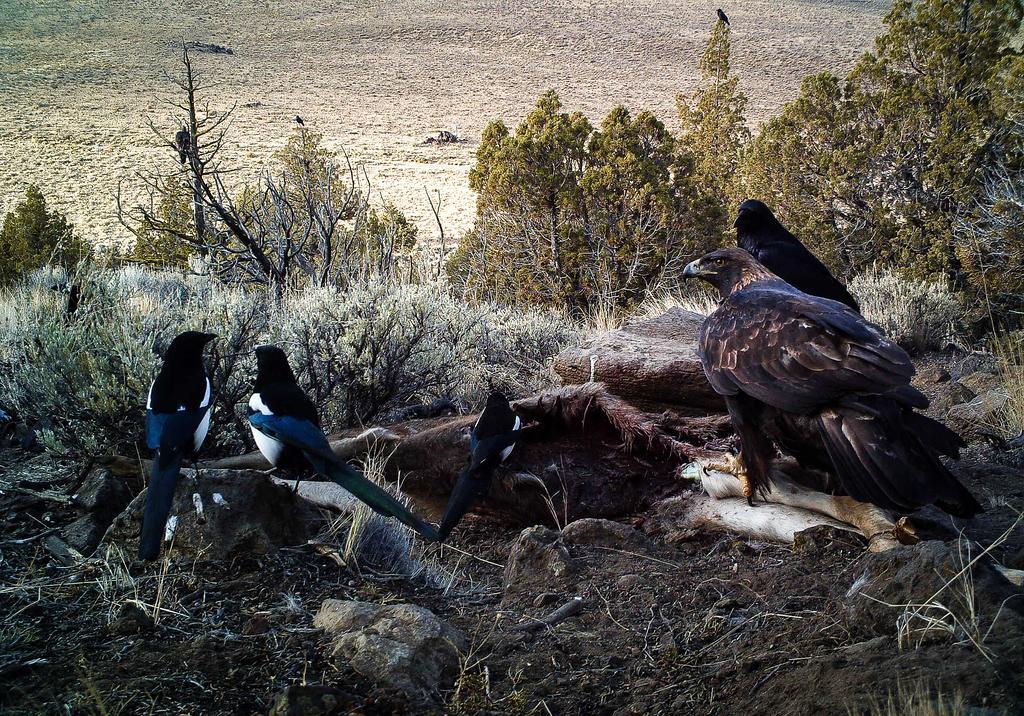Can you describe this image briefly? In this image, we can see some trees. There are birds in the middle of the image. There are some plants on the left side of the image. 